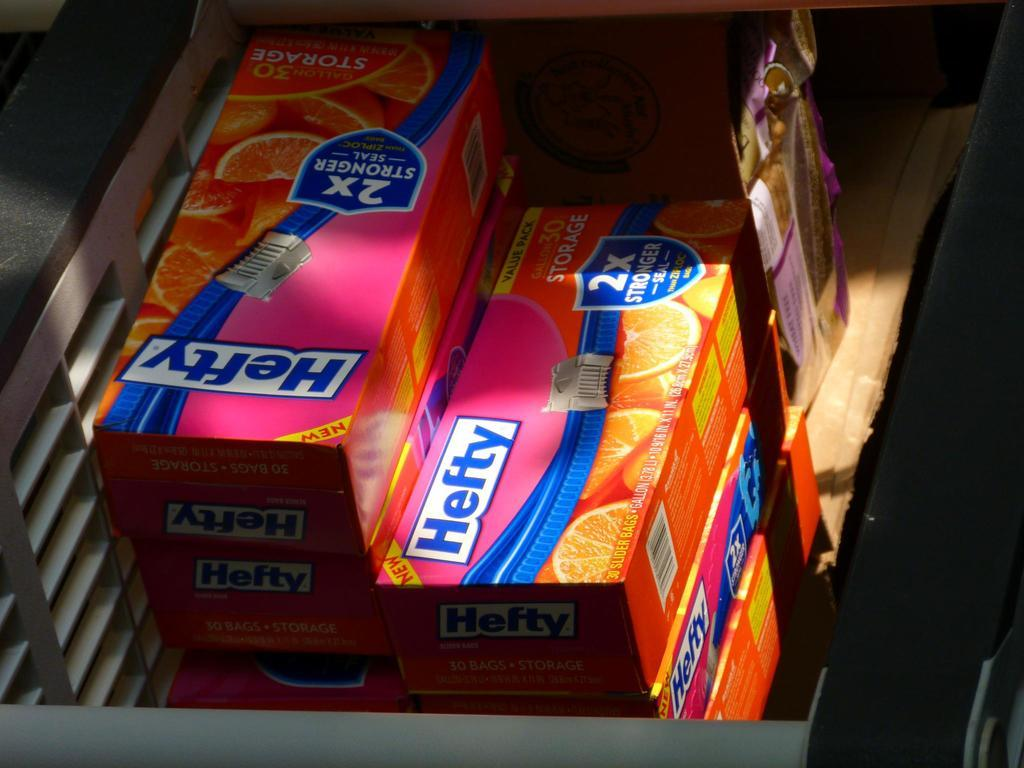What type of objects in the image have text on them? There are boxes with text in the image. What can be seen on the object with images? Images are placed on an object in the image. What type of hope can be seen in the image? There is no reference to hope in the image, so it is not possible to determine what, if any, hope might be present. 